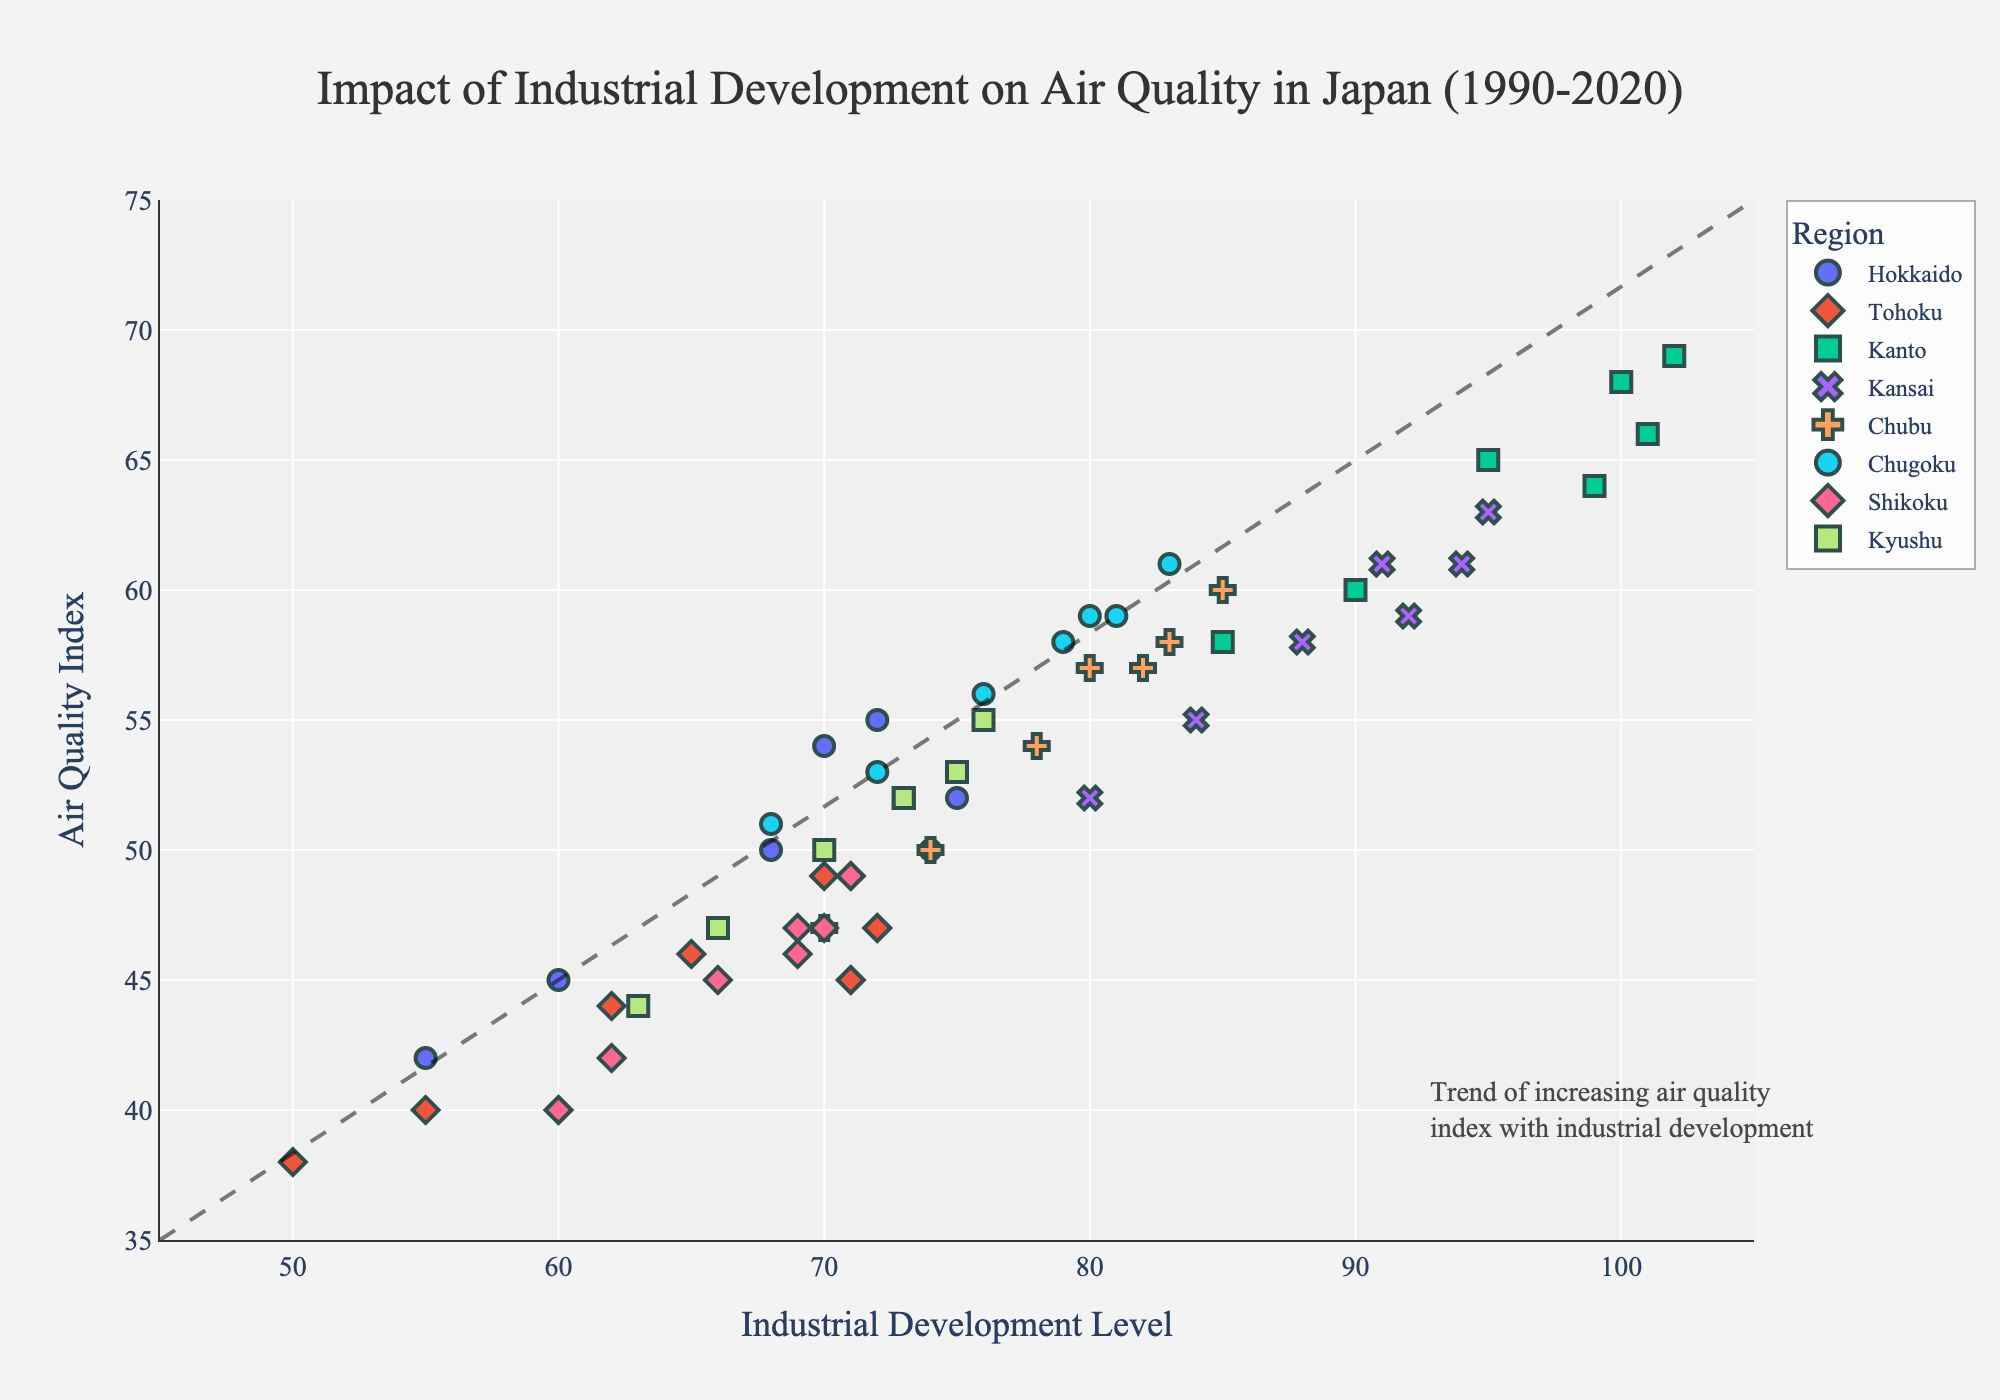What is the title of the plot? The title is prominently displayed at the top of the plot and provides a summary of the chart's content.
Answer: Impact of Industrial Development on Air Quality in Japan (1990-2020) How many regions are represented in the plot? The legend on the right side of the plot lists each region included in the dataset.
Answer: 8 What is the range of the Industrial Development Level axis? The x-axis, labeled "Industrial Development Level," ranges from the minimum to the maximum values indicated on the axis.
Answer: 45 to 105 What is the relationship between the Industrial Development Level and Air Quality Index for most regions? The trend line added in the plot shows a general direction indicating the relationship.
Answer: Increasing industrial development generally correlates with higher air quality indexes In which year did Kanto have the highest Air Quality Index? The size of the markers represents the year, and the hover data for Kanto can be checked to find the highest Air Quality Index.
Answer: 2010 By how much did the Air Quality Index change in Hokkaido from 1990 to 2020? Look at the starting and ending points for Hokkaido on the y-axis and calculate the difference.
Answer: Increased by 8 points Which region showed the highest Air Quality Index in the latest year (2020)? Identify the markers for 2020 and check which has the highest position on the y-axis.
Answer: Kanto Does any region show a decrease in the Air Quality Index over the time period? Look at the trend within each region by examining the positions of their markers over time.
Answer: Some regions, such as Shikoku and Kyushu, show slight decreases towards the end What is the average Industrial Development Level for Kansai over the years? Add up all the Industrial Development Levels for Kansai and divide by the number of years data is provided for.
Answer: (80 + 84 + 88 + 91 + 95 + 94 + 92) / 7 = 89.14 Which region had the most significant increase in Industrial Development Level from 1990 to 2020? Compare the differences in Industrial Development Level from 1990 to 2020 for each region.
Answer: Kanto (With an increase from 85 to 99) 